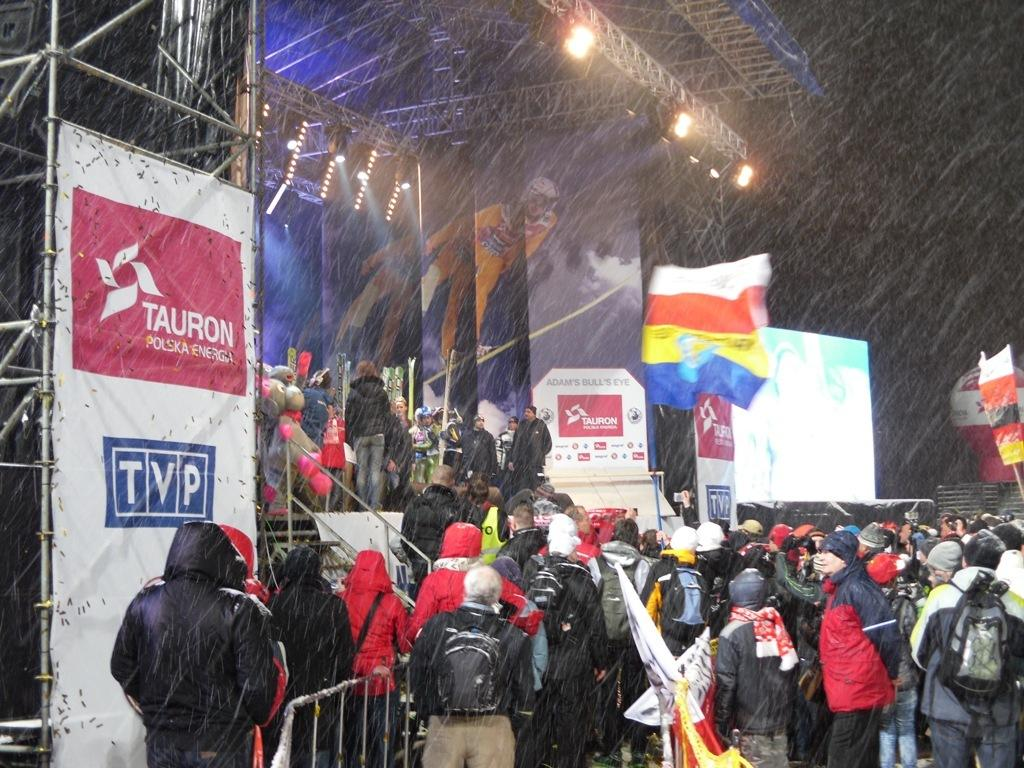What can be seen in the image that represents a symbol or country? There are flags in the image. What items are present that might be used for carrying or holding things? There are bags and jackets in the image. What type of signage or advertisement is visible in the image? There are banners in the image. What electronic devices are present in the image? There are screens in the image. What type of illumination is visible in the image? There are lights in the image. What type of support structure is present in the image? There are rods in the image. What type of barrier is present in the image? There is a fence in the image. What type of decorative items are present in the image? There are balloons in the image. What can be seen in the image that represents a gathering of people? There is a group of people standing in the image. What is the color of the background in the image? The background of the image is dark. What type of drink is being served to the group of people in the image? The image does not show any drinks being served, so it cannot be determined what type of drink might be present. How quiet is the atmosphere in the image? The image does not provide any information about the noise level or atmosphere, so it cannot be determined how quiet it is. 